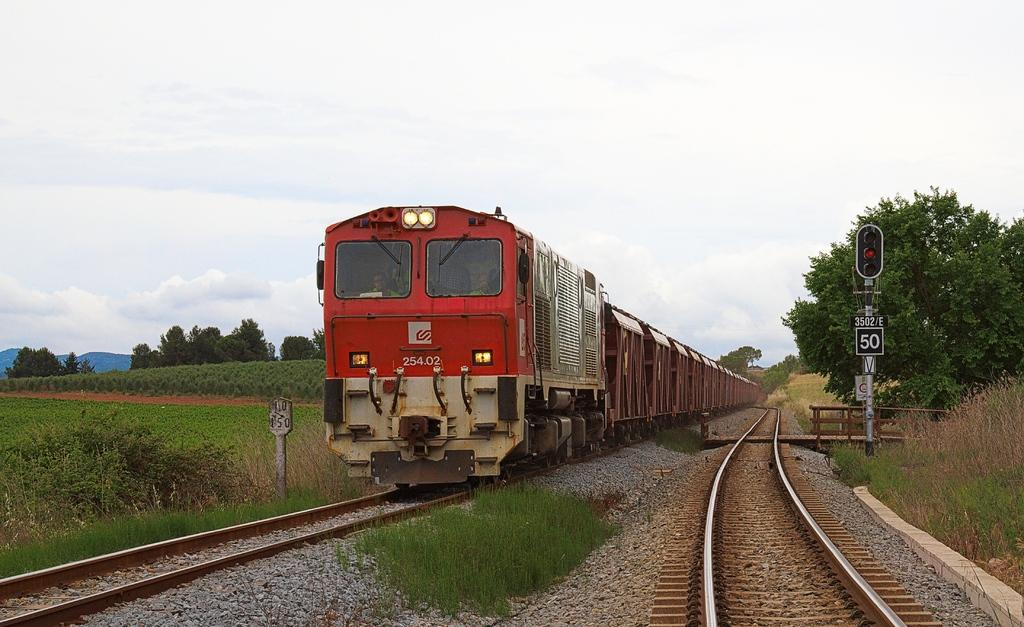<image>
Describe the image concisely. A red train has the numbers 25402 on the front. 